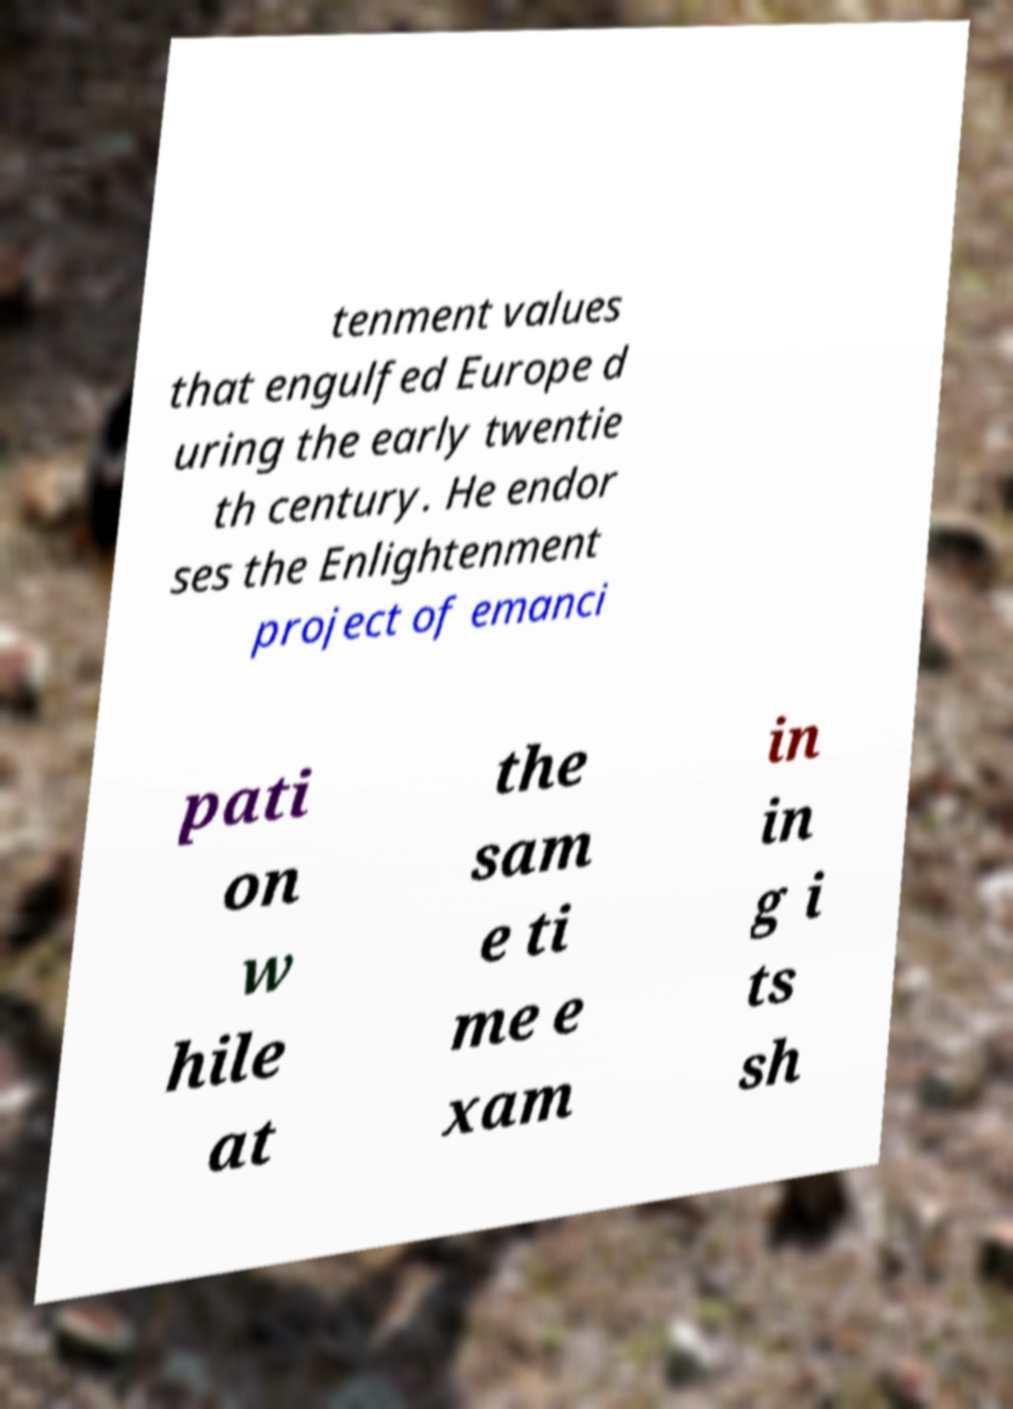Can you accurately transcribe the text from the provided image for me? tenment values that engulfed Europe d uring the early twentie th century. He endor ses the Enlightenment project of emanci pati on w hile at the sam e ti me e xam in in g i ts sh 